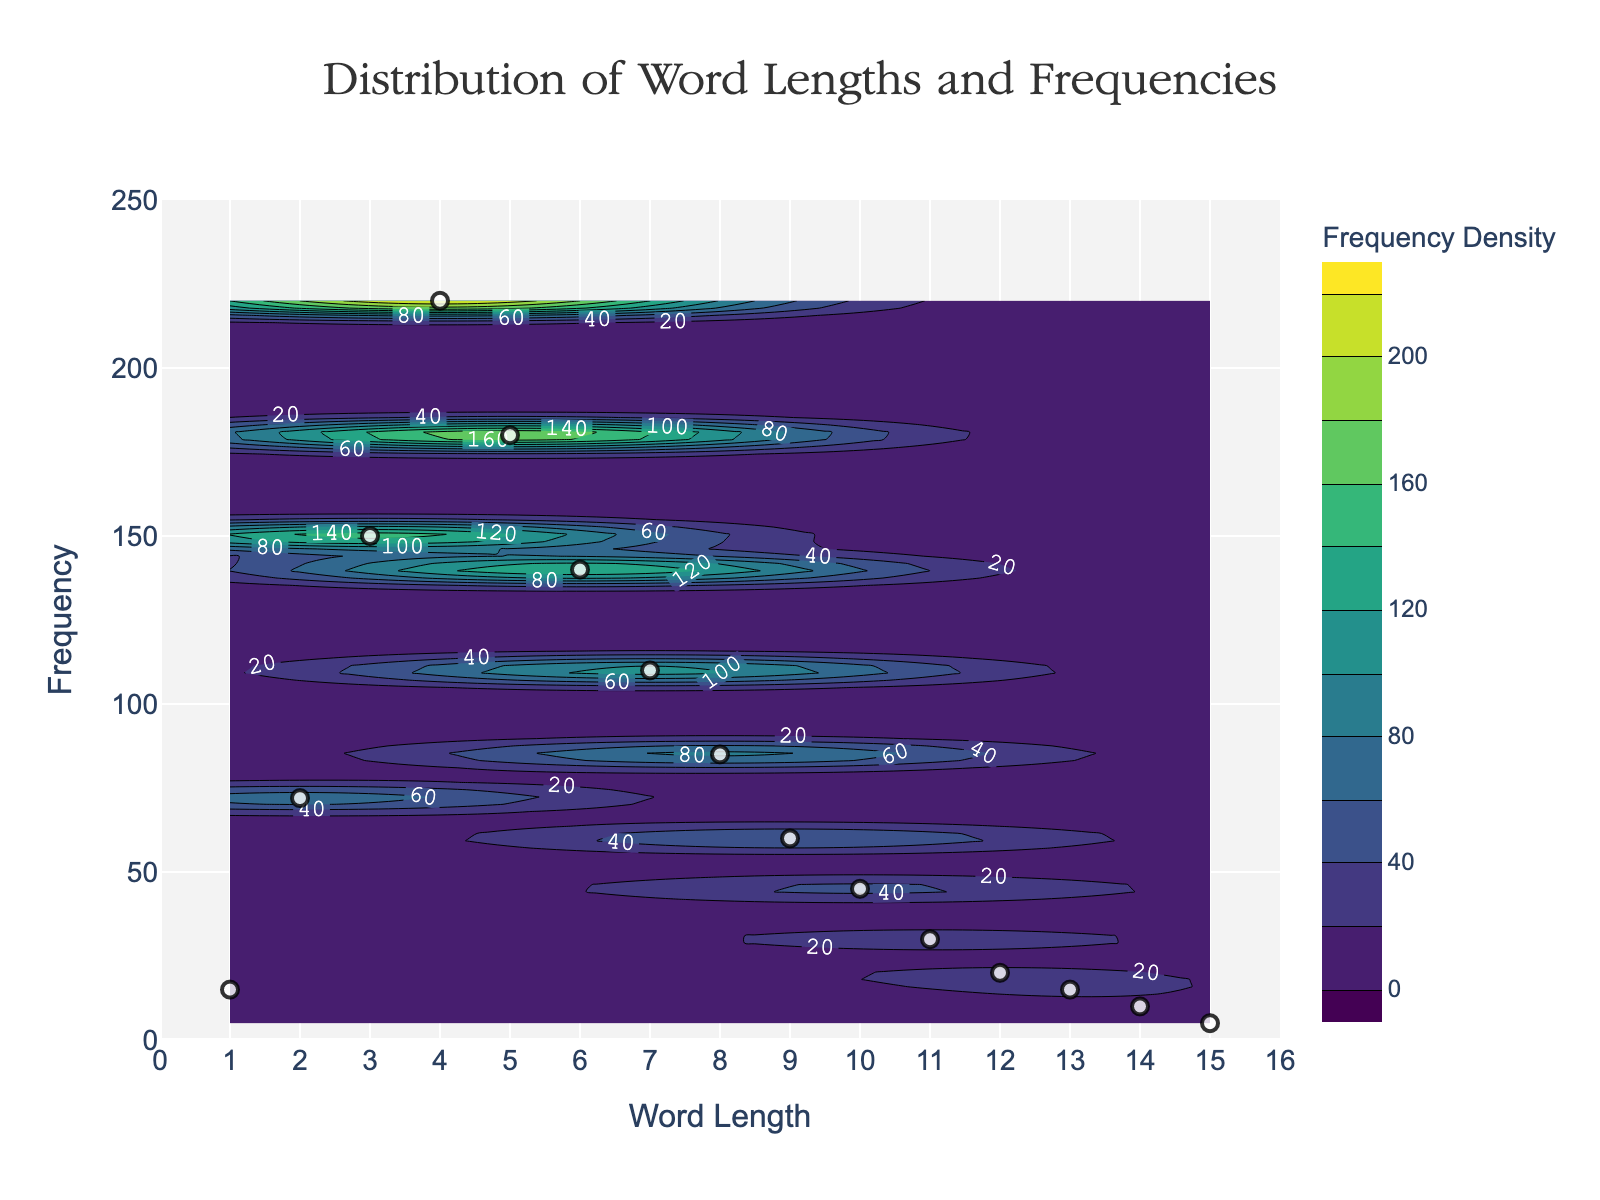What is the title of the plot? The title is positioned at the top center of the plot. It reads "Distribution of Word Lengths and Frequencies."
Answer: Distribution of Word Lengths and Frequencies What are the x-axis and y-axis labeled as? The labels can be found at the bottom and left side of the plot. The x-axis is labeled "Word Length" and the y-axis is labeled "Frequency."
Answer: Word Length and Frequency How many data points are plotted as scatter markers? Count the number of white scatter markers representing the data points in the plot. There are 15 markers, each corresponding to a word length from 1 to 15.
Answer: 15 What is the color scheme used for the contour plot? The contour plot employs a color scale. The colors range from dark purple to yellow, indicating varying frequency densities, as part of the Viridis color scale.
Answer: Viridis What word length has the highest frequency, and what is that frequency? Identify the data point (scatter marker) that is positioned at the highest frequency on the y-axis. The word length is 4, and the highest frequency is 220.
Answer: Word length 4 and frequency 220 Which word length is associated with the lowest frequency, and what is the frequency? Locate the data point (scatter marker) that is positioned at the lowest frequency on the y-axis. The word length is 15, and the frequency is 5.
Answer: Word length 15 and frequency 5 Compare the frequencies of word lengths 5 and 10. Which has a higher frequency? Identify and compare the scatter markers for word lengths 5 and 10. The frequency for word length 5 is 180, while the frequency for word length 10 is 45. Word length 5 has a higher frequency.
Answer: Word length 5 What's the average frequency of word lengths 5, 6, and 7? Sum the frequencies for word lengths 5, 6, and 7 (180 + 140 + 110) and divide by 3 to calculate the average frequency: (180 + 140 + 110) / 3 = 430 / 3 = 143.33.
Answer: 143.33 Explain the general trend of frequencies as word lengths increase. Observe the scatter plot markers. Frequencies show an increasing trend up to word lengths 4-5, then gradually decrease as word lengths increase further.
Answer: Increase then decrease Which contour level is the densest according to the plot's color scale? Examine the contour levels labeled on the plot. The darkest purple regions indicate the highest density, which are located around the word length 4 with the highest frequency.
Answer: Around word length 4 